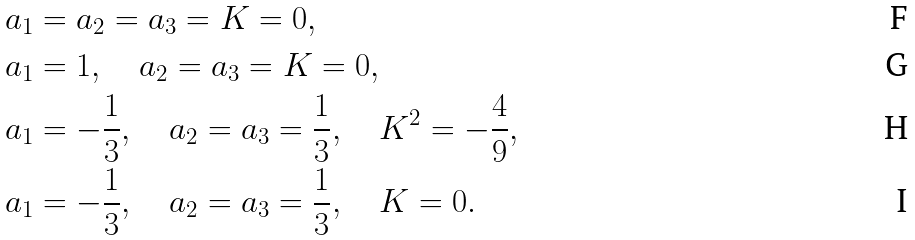Convert formula to latex. <formula><loc_0><loc_0><loc_500><loc_500>a _ { 1 } & = a _ { 2 } = a _ { 3 } = K = 0 , \\ a _ { 1 } & = 1 , \quad a _ { 2 } = a _ { 3 } = K = 0 , \\ a _ { 1 } & = - \frac { 1 } { 3 } , \quad a _ { 2 } = a _ { 3 } = \frac { 1 } { 3 } , \quad K ^ { 2 } = - \frac { 4 } { 9 } , \\ a _ { 1 } & = - \frac { 1 } { 3 } , \quad a _ { 2 } = a _ { 3 } = \frac { 1 } { 3 } , \quad K = 0 .</formula> 